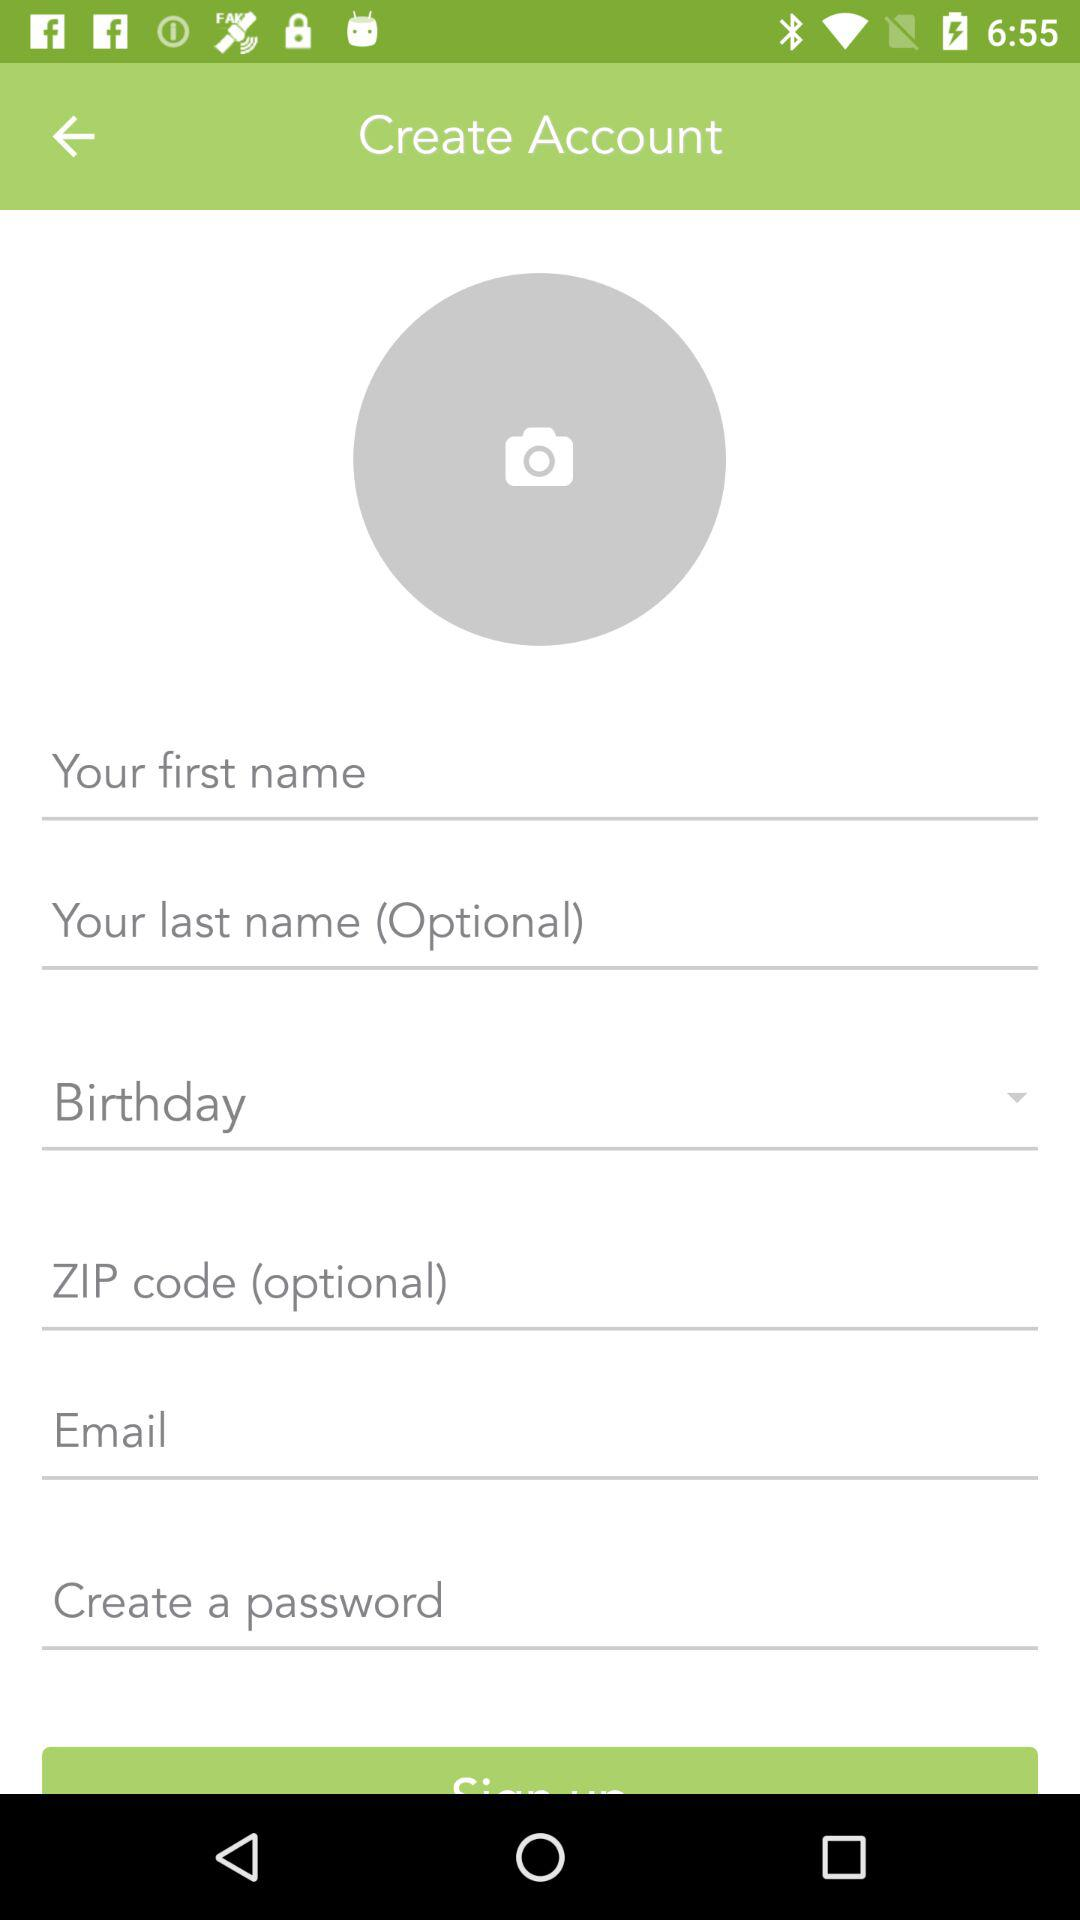How many input fields are optional to create an account?
Answer the question using a single word or phrase. 2 